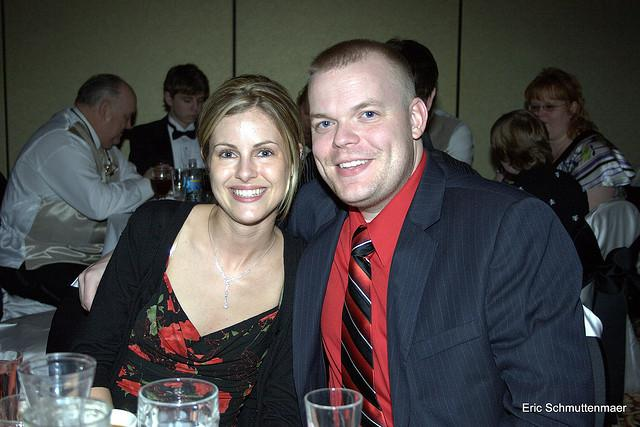Persons here are likely attending what type reception? wedding 